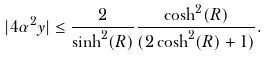<formula> <loc_0><loc_0><loc_500><loc_500>| 4 \alpha ^ { 2 } y | \leq \frac { 2 } { \sinh ^ { 2 } ( R ) } \frac { \cosh ^ { 2 } ( R ) } { ( 2 \cosh ^ { 2 } ( R ) + 1 ) } .</formula> 